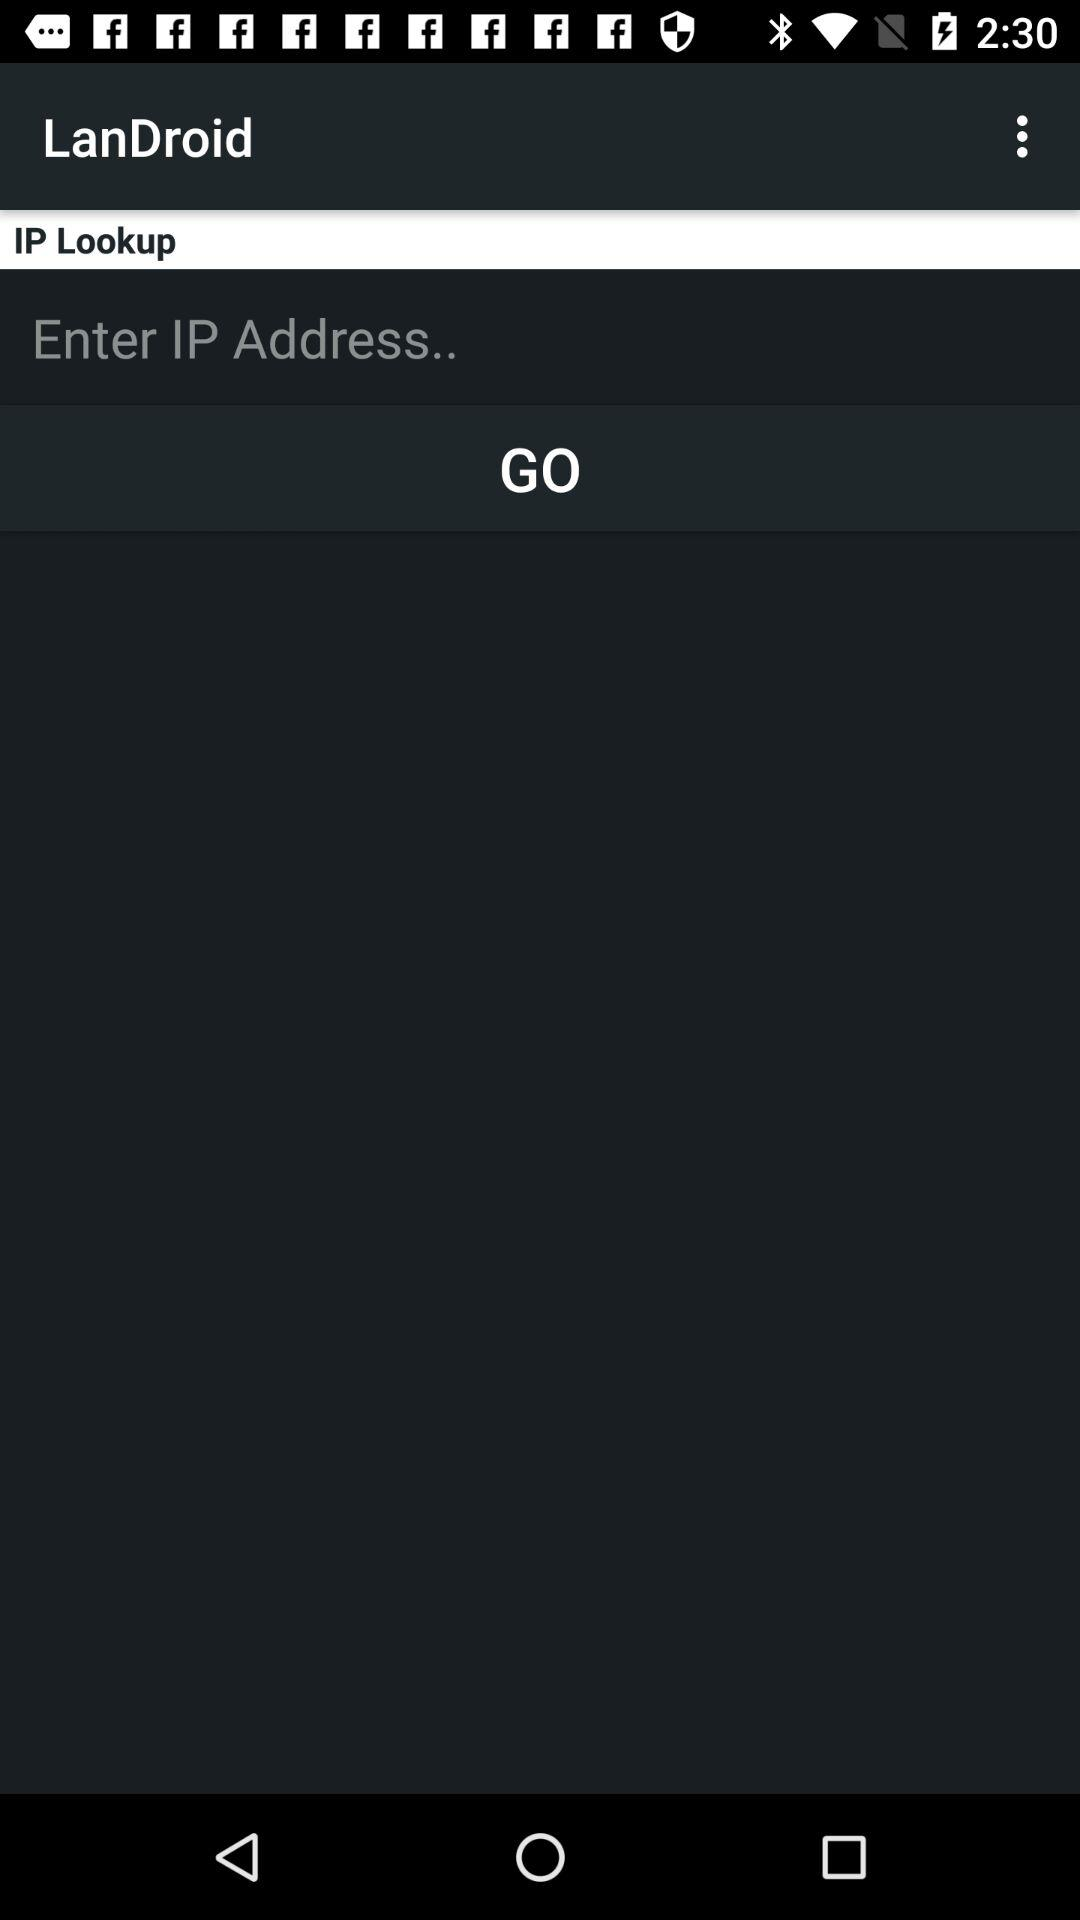What is the name of the application? The name of the application is "LanDroid". 